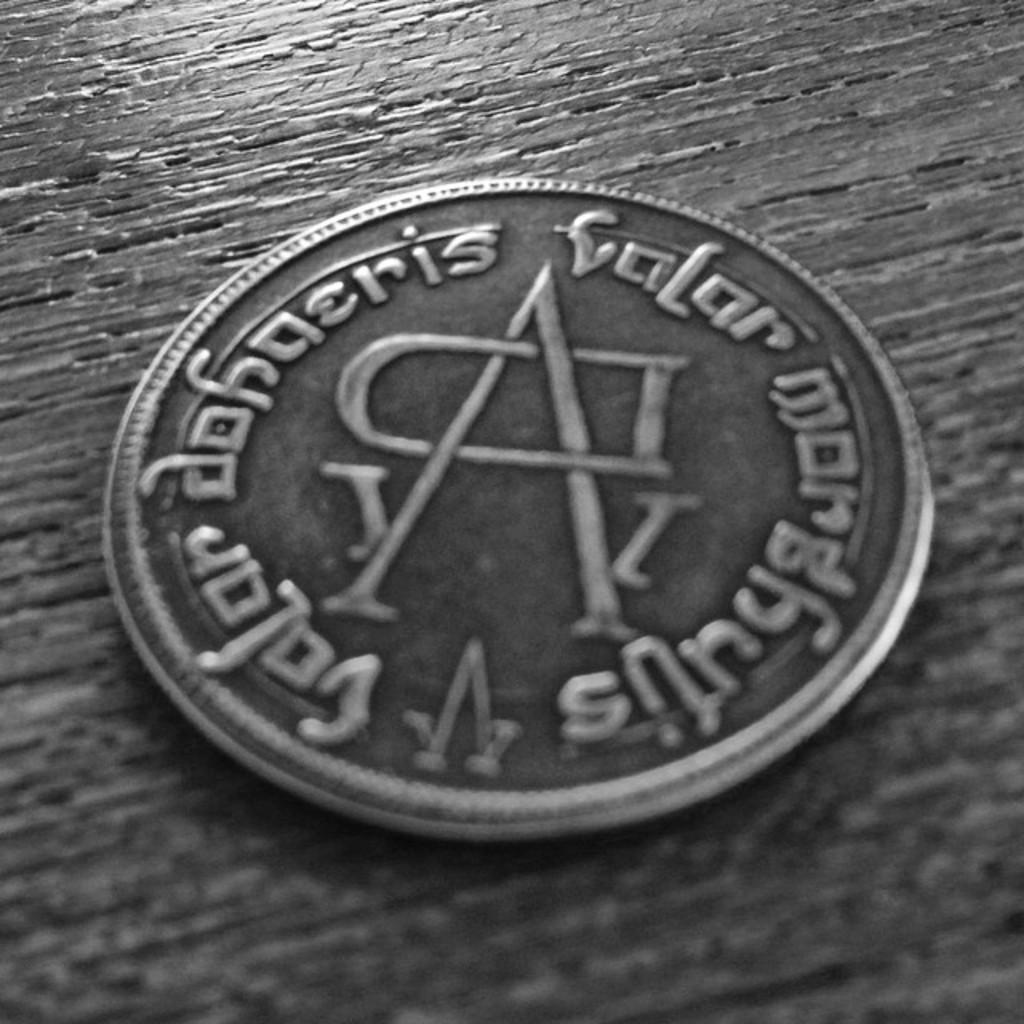What letter is on the coin?
Ensure brevity in your answer.  A. 